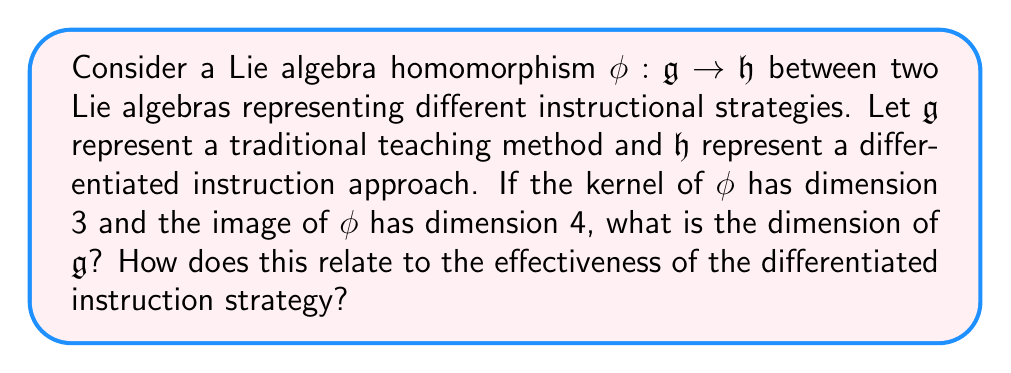Show me your answer to this math problem. To solve this problem, we'll use the fundamental theorem of Lie algebra homomorphisms, which is analogous to the first isomorphism theorem for groups. This theorem states that for a Lie algebra homomorphism $\phi: \mathfrak{g} \rightarrow \mathfrak{h}$:

$$\mathfrak{g} / \ker(\phi) \cong \text{Im}(\phi)$$

Where $\ker(\phi)$ is the kernel of $\phi$ and $\text{Im}(\phi)$ is the image of $\phi$.

Given:
- $\dim(\ker(\phi)) = 3$
- $\dim(\text{Im}(\phi)) = 4$

Let's denote $\dim(\mathfrak{g}) = n$. We need to find $n$.

From the theorem, we know that:

$$\dim(\mathfrak{g}) = \dim(\ker(\phi)) + \dim(\text{Im}(\phi))$$

Substituting the given values:

$$n = 3 + 4 = 7$$

Therefore, the dimension of $\mathfrak{g}$ is 7.

Interpreting this result in the context of differentiated instruction:
The dimension of $\mathfrak{g}$ (7) represents the total number of "components" or "aspects" in the traditional teaching method. The kernel (dimension 3) represents the aspects that are not carried over to the differentiated instruction approach, while the image (dimension 4) represents the aspects that are preserved or transformed in the new approach.

The effectiveness of the differentiated instruction strategy can be assessed by comparing the dimensions:
1. $\dim(\text{Im}(\phi)) > \dim(\ker(\phi))$: This suggests that more components of the traditional method are preserved or adapted in the differentiated approach than are discarded, indicating a potentially effective transition.
2. $\dim(\text{Im}(\phi)) = 4$ out of $\dim(\mathfrak{g}) = 7$: Approximately 57% of the original method's components are utilized in the new approach, suggesting a significant adaptation while maintaining some continuity.

This analysis provides a quantitative framework for evaluating the extent of change and preservation in transitioning from traditional to differentiated instruction methods.
Answer: The dimension of $\mathfrak{g}$ is 7. This result suggests that the differentiated instruction strategy effectively adapts more than half of the components from the traditional method, potentially indicating a balanced and effective transition to a new teaching approach. 